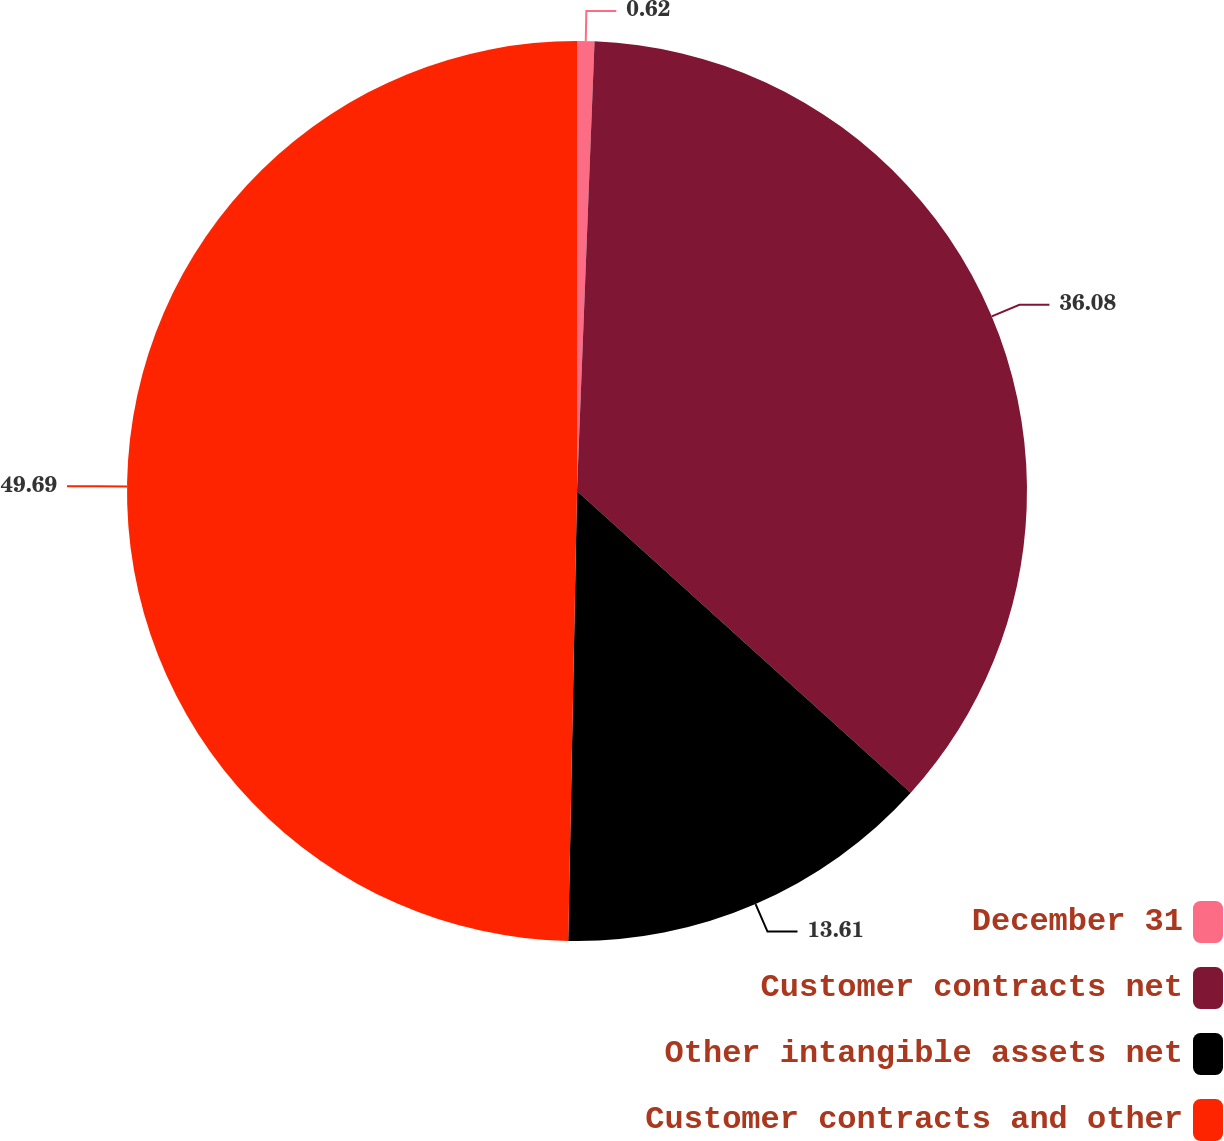Convert chart. <chart><loc_0><loc_0><loc_500><loc_500><pie_chart><fcel>December 31<fcel>Customer contracts net<fcel>Other intangible assets net<fcel>Customer contracts and other<nl><fcel>0.62%<fcel>36.08%<fcel>13.61%<fcel>49.69%<nl></chart> 